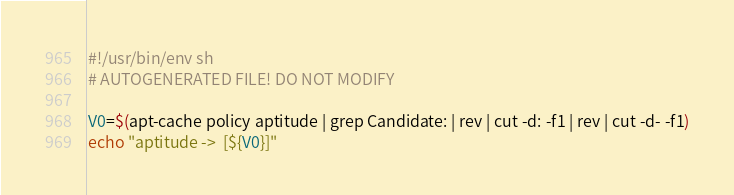<code> <loc_0><loc_0><loc_500><loc_500><_Bash_>#!/usr/bin/env sh
# AUTOGENERATED FILE! DO NOT MODIFY

V0=$(apt-cache policy aptitude | grep Candidate: | rev | cut -d: -f1 | rev | cut -d- -f1)
echo "aptitude ->  [${V0}]"
</code> 